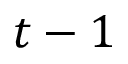<formula> <loc_0><loc_0><loc_500><loc_500>t - 1</formula> 